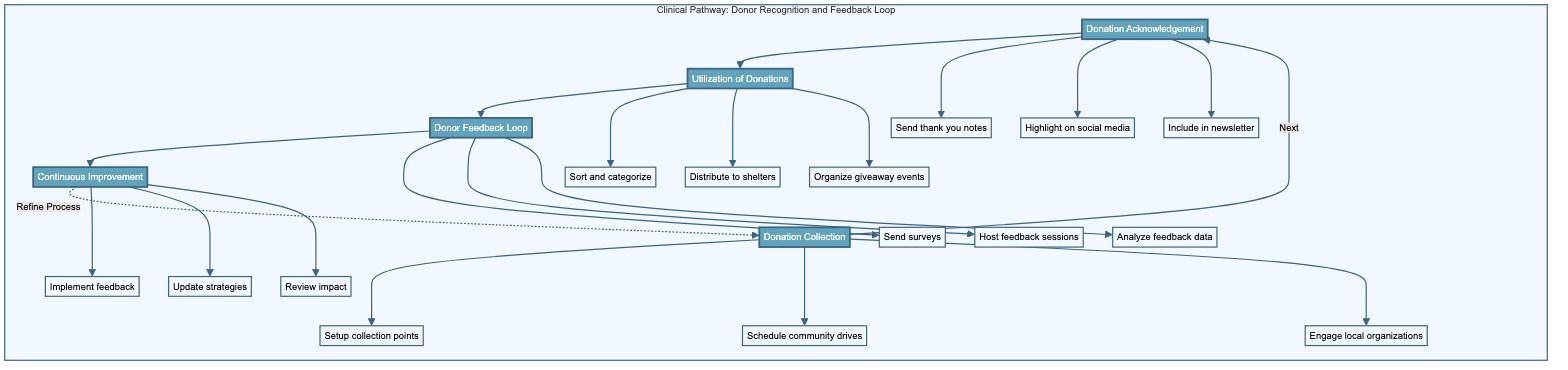What is the first stage in the clinical pathway? The first stage labeled in the diagram is "Donation Collection." It is the starting point of the clinical pathway from which all subsequent actions flow.
Answer: Donation Collection How many key actions are there in the "Donor Feedback Loop" stage? In the "Donor Feedback Loop" stage, there are three key actions listed: "Send surveys," "Host feedback sessions," and "Analyze feedback data." Counting these gives us a total of three key actions.
Answer: 3 What key action involves community outreach during donation collection? The key action specifically related to community outreach during the "Donation Collection" stage is "Engage local organizations." This is focused on building partnerships for support in the collection of donations.
Answer: Engage local organizations Which stage connects directly to the "Continuous Improvement" stage? The "Donor Feedback Loop" stage directly connects to the "Continuous Improvement" stage according to the flow of the clinical pathway. This relationship indicates that feedback is essential for the improvement process.
Answer: Donor Feedback Loop What is emphasized in the "Donation Acknowledgement" stage? The primary emphasis in the "Donation Acknowledgement" stage is on recognizing and thanking donors for their contributions. This builds a positive relationship and encourages future donations.
Answer: Recognize and thank donors What is the relationship between "Utilization of Donations" and "Donation Acknowledgement"? The "Utilization of Donations" stage follows directly after "Donation Acknowledgement" in the pathway, which indicates that after donors are acknowledged, their donations are put to use efficiently.
Answer: Sequential connection How does feedback from donors impact the donation process? Feedback from donors plays a crucial role in "Continuous Improvement," where actionable insights from feedback are implemented to refine donation processes, enhancing overall effectiveness.
Answer: Refine processes In which stage are follow-up surveys sent to donors? Follow-up surveys are sent in the "Donor Feedback Loop" stage, which is designed to gather input and assess donor satisfaction regarding the donation process.
Answer: Donor Feedback Loop How many total stages are illustrated in the diagram? The diagram illustrates a total of five distinct stages, providing a complete view of the clinical pathway related to donor recognition and feedback. Counting these stages confirms the total.
Answer: 5 